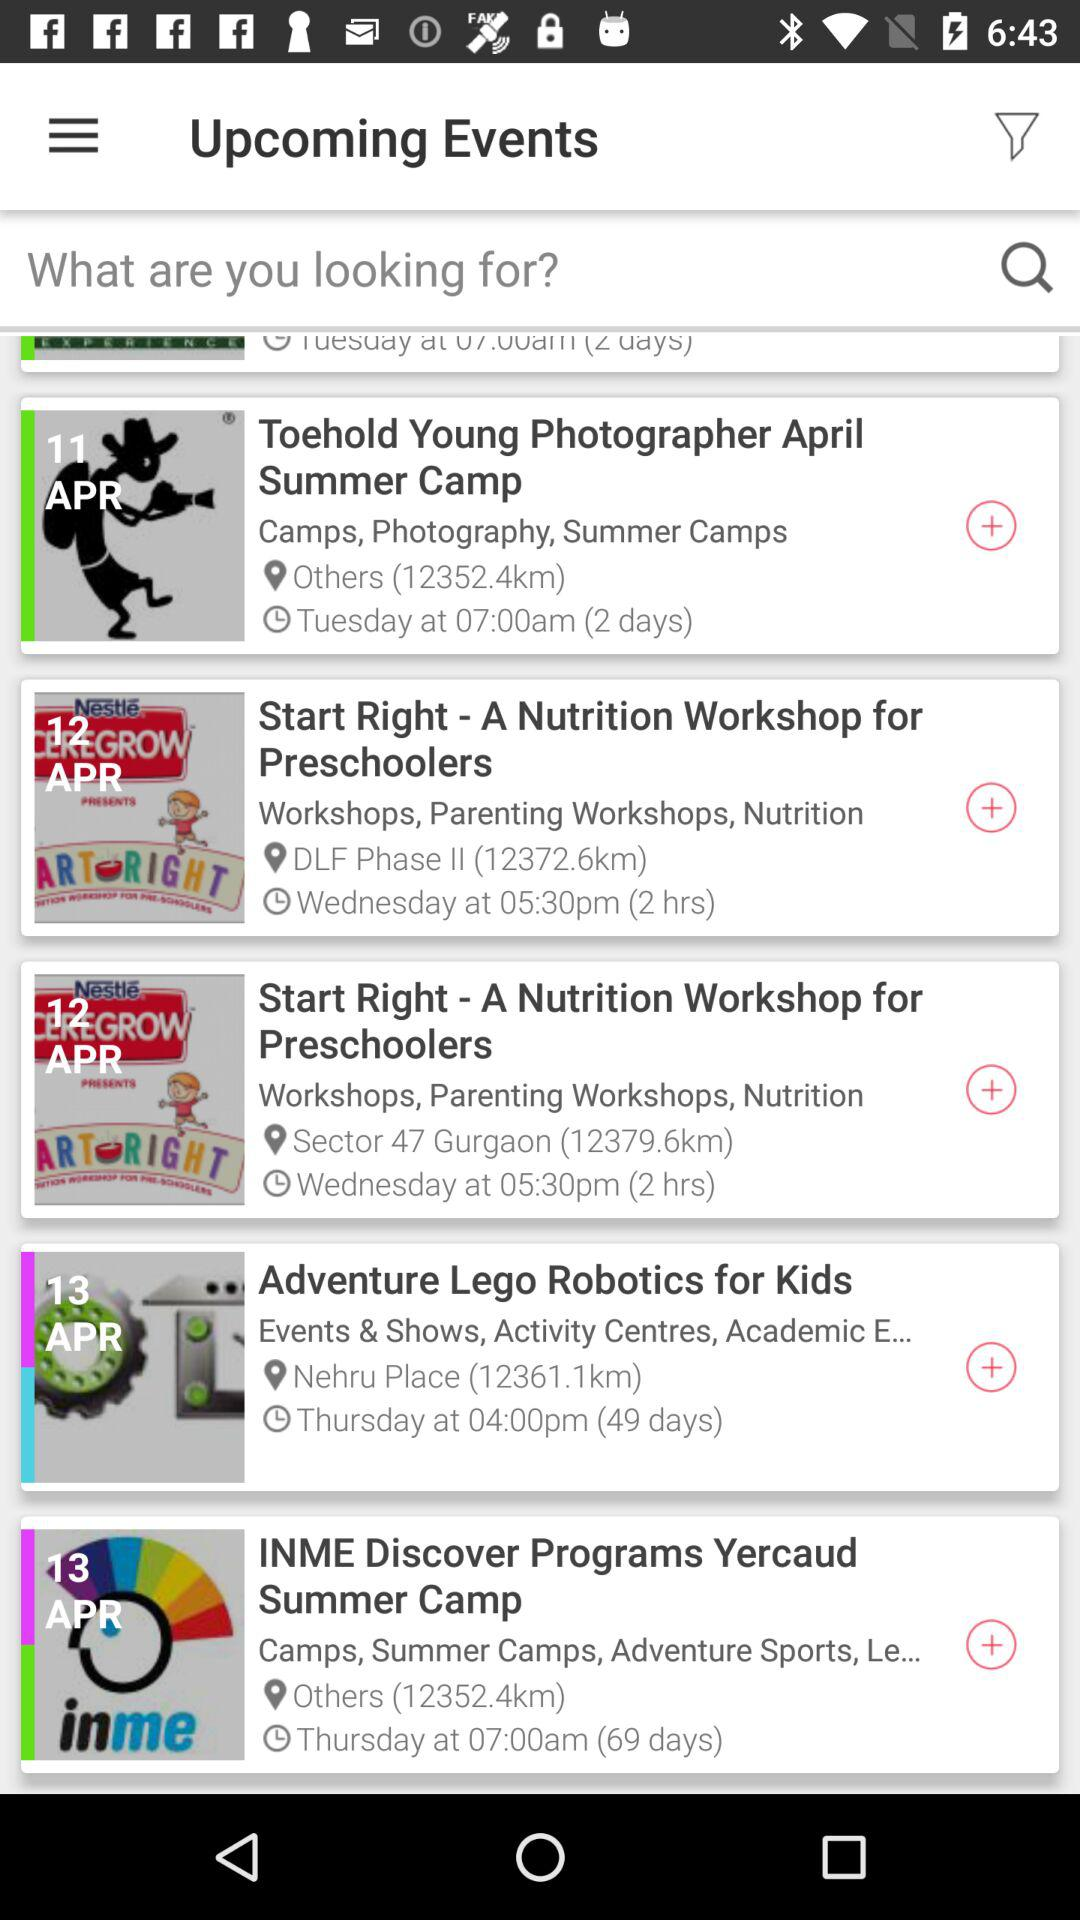What is the given distance of "INME discover programs Yercaud Summer Camp"? The distance is 12352.4 KM. 